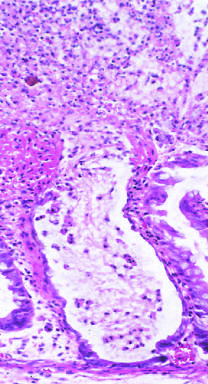where are the neutrophils emanating from?
Answer the question using a single word or phrase. The crypt 